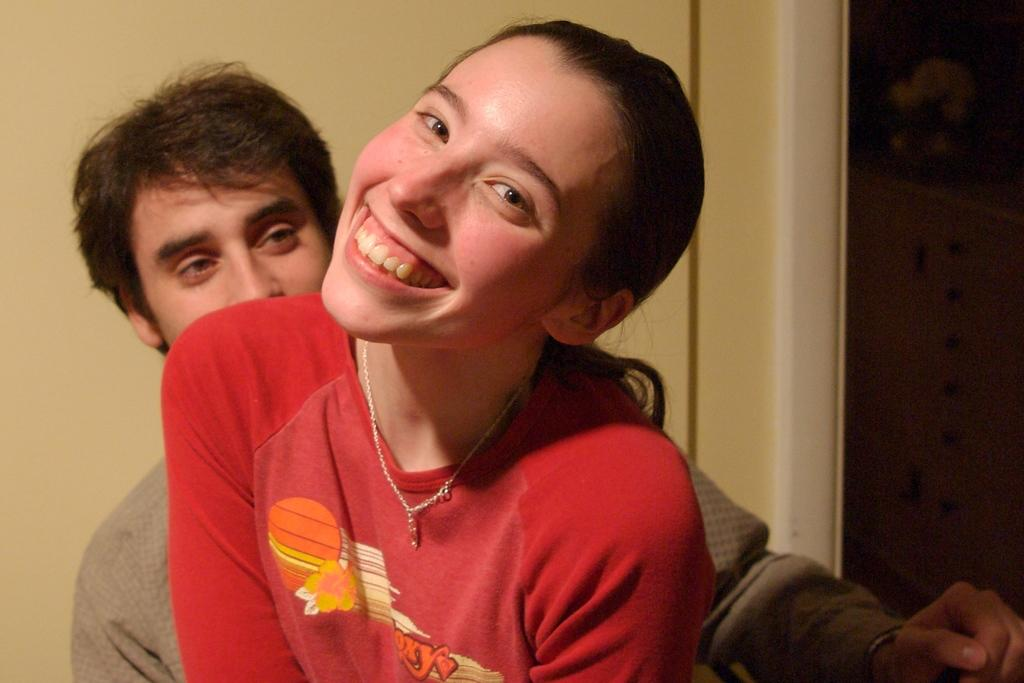How many people are in the image? There are two persons in the image. What can be observed about their appearance? The two persons are in different costumes. Can you describe the facial expression of one of the persons? One of the persons is smiling. What is visible in the background of the image? There is a wall in the background of the image. What type of jar is being used for driving in the image? There is no jar or driving activity present in the image. Can you describe the fangs of the person in the image? There are no fangs visible on either person in the image. 